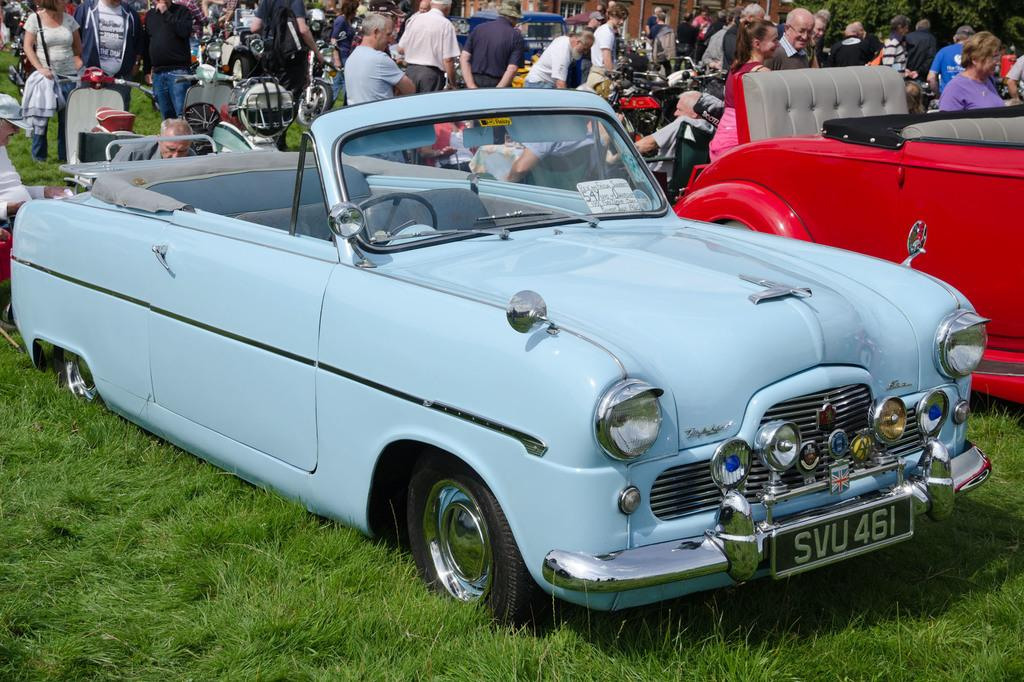What types of objects can be seen in the image? There are vehicles in the image. What are the people in the image doing? There are people walking and standing in the image. What type of surface is visible in the image? The surface of the grass is visible in the image. What type of engine can be seen powering the secretary in the image? There is no secretary or engine present in the image. How many screws are visible on the people in the image? There are no screws visible on the people in the image. 